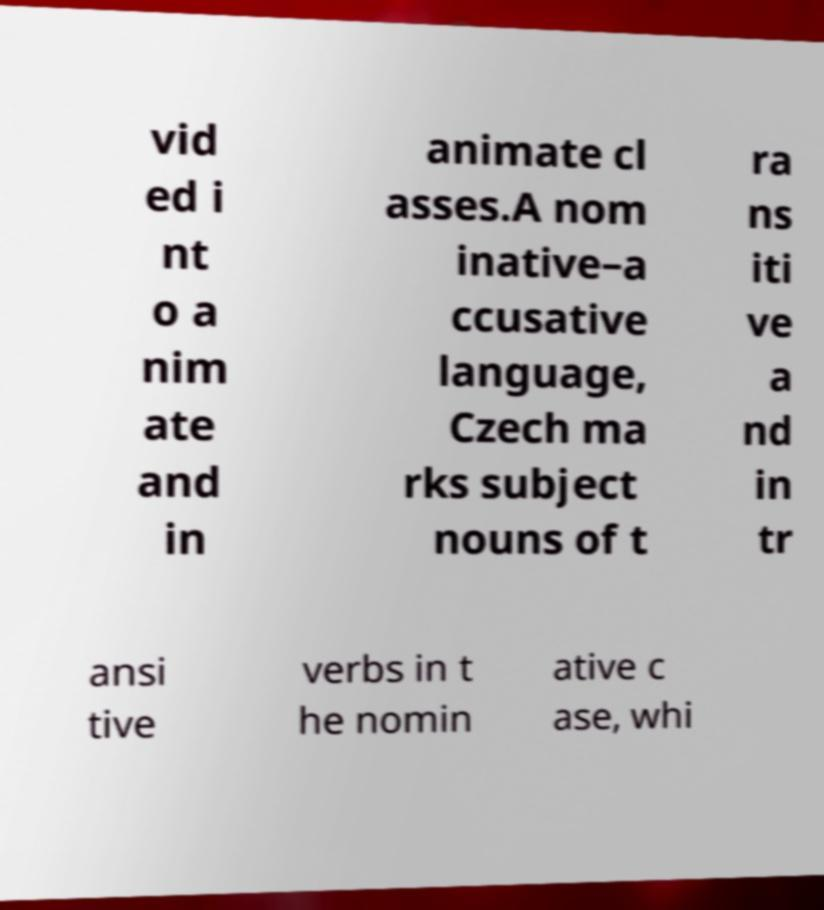Please identify and transcribe the text found in this image. vid ed i nt o a nim ate and in animate cl asses.A nom inative–a ccusative language, Czech ma rks subject nouns of t ra ns iti ve a nd in tr ansi tive verbs in t he nomin ative c ase, whi 